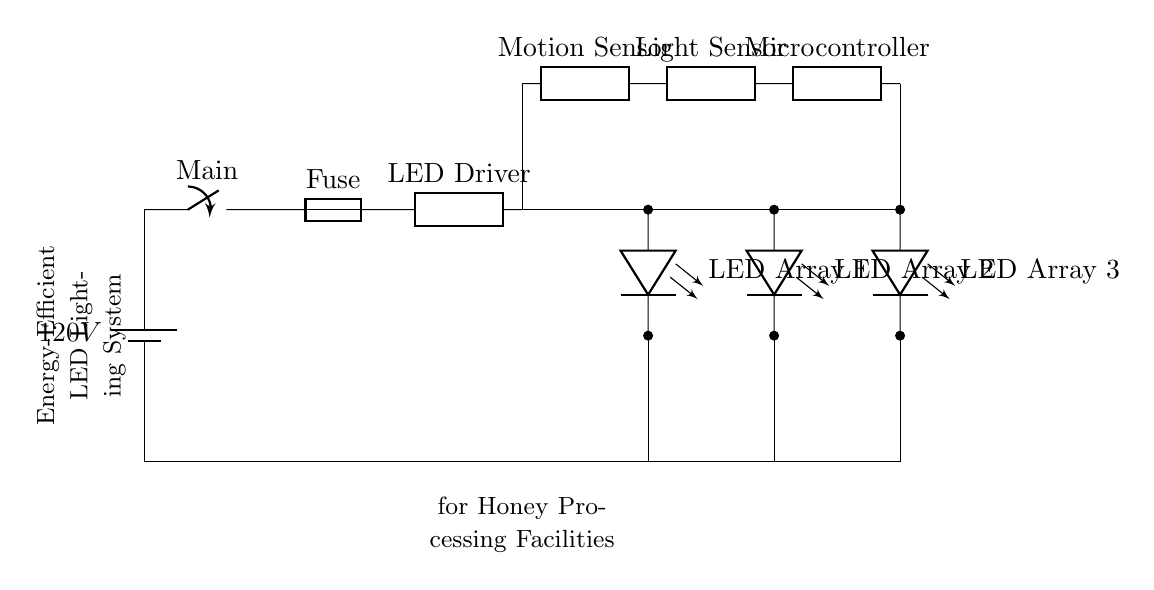What is the main power source voltage? The main power source is a battery labeled with a voltage of 120V, which can be seen at the beginning of the circuit diagram.
Answer: 120V What type of lighting does this system use? The diagram shows multiple LED arrays labeled as 'LED Array 1', 'LED Array 2', and 'LED Array 3', indicating that the system utilizes LED lighting technology.
Answer: LED How many LED arrays are present in the circuit? The diagram indicates three distinct LED arrays, each connected in parallel within the circuit, which can be counted from the sequence shown.
Answer: 3 What controls the lighting based on movement? The circuit includes a component labeled 'Motion Sensor', which is responsible for detecting motion and controlling the lighting accordingly.
Answer: Motion Sensor What is the function of the microcontroller in this circuit? The microcontroller is connected to the light sensor and the motion sensor, suggesting its role is to process inputs from these sensors and control the LED arrays based on that information.
Answer: Control logic What connects the LED driver to the LED arrays? The LED driver is directly connected to the three LED arrays through wires shown in the diagram, which implies it manages the flow of electrical energy to those arrays.
Answer: Wires What type of sensors are used in this circuit? The circuit features both a motion sensor and a light sensor, indicating that it is designed to respond to both presence and ambient light conditions.
Answer: Motion and Light Sensor 